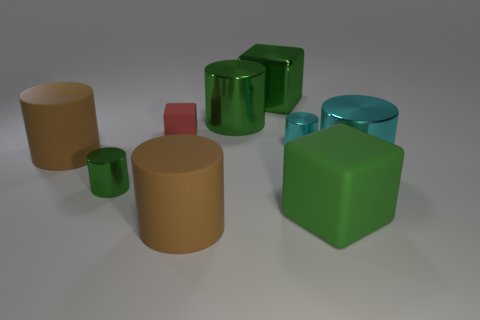Does the cyan thing behind the large cyan object have the same shape as the large green object that is to the left of the large metallic cube?
Offer a very short reply. Yes. How many other things are there of the same color as the big rubber cube?
Give a very brief answer. 3. There is a metal object to the right of the green rubber block; is it the same size as the metallic cube?
Ensure brevity in your answer.  Yes. Does the large cube in front of the tiny red thing have the same material as the large green object on the left side of the big green shiny cube?
Your answer should be compact. No. Are there any metallic cylinders of the same size as the green shiny cube?
Your answer should be very brief. Yes. The rubber object that is behind the small metal object on the right side of the large metal cube to the right of the red rubber object is what shape?
Make the answer very short. Cube. Is the number of green matte things that are behind the small green shiny object greater than the number of large cyan metal things?
Give a very brief answer. No. Are there any large green metallic objects of the same shape as the big cyan object?
Provide a succinct answer. Yes. Are the tiny cube and the brown thing in front of the small green metal thing made of the same material?
Ensure brevity in your answer.  Yes. What is the color of the large metallic cube?
Your answer should be compact. Green. 